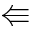<formula> <loc_0><loc_0><loc_500><loc_500>\L l e f t a r r o w</formula> 